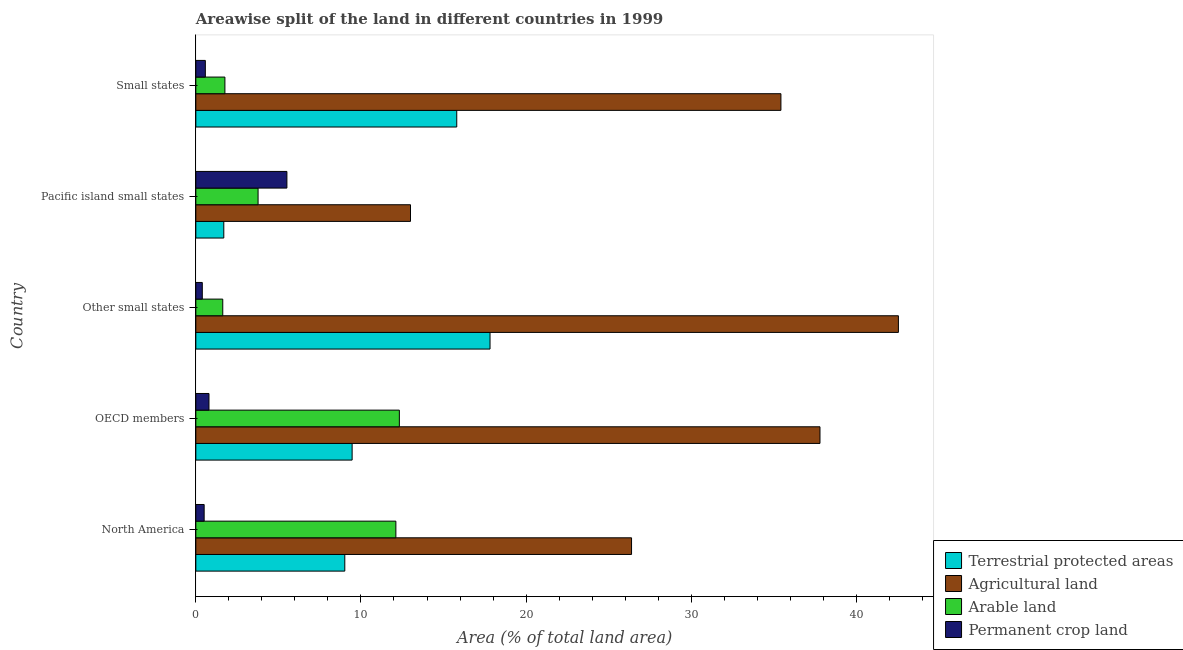Are the number of bars per tick equal to the number of legend labels?
Make the answer very short. Yes. How many bars are there on the 3rd tick from the top?
Your response must be concise. 4. In how many cases, is the number of bars for a given country not equal to the number of legend labels?
Make the answer very short. 0. What is the percentage of land under terrestrial protection in Pacific island small states?
Give a very brief answer. 1.69. Across all countries, what is the maximum percentage of land under terrestrial protection?
Keep it short and to the point. 17.82. Across all countries, what is the minimum percentage of land under terrestrial protection?
Your response must be concise. 1.69. In which country was the percentage of land under terrestrial protection maximum?
Your response must be concise. Other small states. In which country was the percentage of area under agricultural land minimum?
Your answer should be very brief. Pacific island small states. What is the total percentage of area under permanent crop land in the graph?
Ensure brevity in your answer.  7.78. What is the difference between the percentage of land under terrestrial protection in North America and that in Other small states?
Make the answer very short. -8.79. What is the difference between the percentage of land under terrestrial protection in Pacific island small states and the percentage of area under permanent crop land in Small states?
Your answer should be very brief. 1.12. What is the average percentage of area under permanent crop land per country?
Provide a short and direct response. 1.56. What is the difference between the percentage of land under terrestrial protection and percentage of area under agricultural land in North America?
Ensure brevity in your answer.  -17.36. In how many countries, is the percentage of area under permanent crop land greater than 30 %?
Your answer should be compact. 0. What is the ratio of the percentage of area under arable land in North America to that in Other small states?
Provide a short and direct response. 7.43. Is the percentage of area under agricultural land in OECD members less than that in Pacific island small states?
Your answer should be very brief. No. Is the difference between the percentage of area under arable land in OECD members and Small states greater than the difference between the percentage of area under permanent crop land in OECD members and Small states?
Provide a short and direct response. Yes. What is the difference between the highest and the second highest percentage of area under permanent crop land?
Your answer should be very brief. 4.72. What is the difference between the highest and the lowest percentage of area under arable land?
Your answer should be very brief. 10.69. Is it the case that in every country, the sum of the percentage of land under terrestrial protection and percentage of area under arable land is greater than the sum of percentage of area under agricultural land and percentage of area under permanent crop land?
Provide a short and direct response. Yes. What does the 2nd bar from the top in North America represents?
Give a very brief answer. Arable land. What does the 1st bar from the bottom in Other small states represents?
Keep it short and to the point. Terrestrial protected areas. Are all the bars in the graph horizontal?
Offer a terse response. Yes. How many countries are there in the graph?
Provide a short and direct response. 5. What is the difference between two consecutive major ticks on the X-axis?
Make the answer very short. 10. Does the graph contain any zero values?
Keep it short and to the point. No. Does the graph contain grids?
Keep it short and to the point. No. How are the legend labels stacked?
Ensure brevity in your answer.  Vertical. What is the title of the graph?
Provide a succinct answer. Areawise split of the land in different countries in 1999. What is the label or title of the X-axis?
Make the answer very short. Area (% of total land area). What is the Area (% of total land area) of Terrestrial protected areas in North America?
Give a very brief answer. 9.02. What is the Area (% of total land area) of Agricultural land in North America?
Offer a very short reply. 26.39. What is the Area (% of total land area) in Arable land in North America?
Make the answer very short. 12.11. What is the Area (% of total land area) of Permanent crop land in North America?
Provide a short and direct response. 0.5. What is the Area (% of total land area) of Terrestrial protected areas in OECD members?
Your response must be concise. 9.47. What is the Area (% of total land area) in Agricultural land in OECD members?
Offer a very short reply. 37.8. What is the Area (% of total land area) of Arable land in OECD members?
Keep it short and to the point. 12.32. What is the Area (% of total land area) of Permanent crop land in OECD members?
Your answer should be compact. 0.8. What is the Area (% of total land area) of Terrestrial protected areas in Other small states?
Keep it short and to the point. 17.82. What is the Area (% of total land area) in Agricultural land in Other small states?
Keep it short and to the point. 42.55. What is the Area (% of total land area) of Arable land in Other small states?
Your answer should be compact. 1.63. What is the Area (% of total land area) of Permanent crop land in Other small states?
Make the answer very short. 0.39. What is the Area (% of total land area) of Terrestrial protected areas in Pacific island small states?
Offer a very short reply. 1.69. What is the Area (% of total land area) in Agricultural land in Pacific island small states?
Make the answer very short. 13. What is the Area (% of total land area) of Arable land in Pacific island small states?
Your answer should be compact. 3.77. What is the Area (% of total land area) in Permanent crop land in Pacific island small states?
Give a very brief answer. 5.52. What is the Area (% of total land area) in Terrestrial protected areas in Small states?
Your response must be concise. 15.8. What is the Area (% of total land area) of Agricultural land in Small states?
Your answer should be very brief. 35.43. What is the Area (% of total land area) of Arable land in Small states?
Offer a very short reply. 1.76. What is the Area (% of total land area) of Permanent crop land in Small states?
Your answer should be very brief. 0.58. Across all countries, what is the maximum Area (% of total land area) in Terrestrial protected areas?
Ensure brevity in your answer.  17.82. Across all countries, what is the maximum Area (% of total land area) of Agricultural land?
Provide a short and direct response. 42.55. Across all countries, what is the maximum Area (% of total land area) in Arable land?
Provide a short and direct response. 12.32. Across all countries, what is the maximum Area (% of total land area) in Permanent crop land?
Give a very brief answer. 5.52. Across all countries, what is the minimum Area (% of total land area) in Terrestrial protected areas?
Offer a very short reply. 1.69. Across all countries, what is the minimum Area (% of total land area) of Agricultural land?
Make the answer very short. 13. Across all countries, what is the minimum Area (% of total land area) in Arable land?
Give a very brief answer. 1.63. Across all countries, what is the minimum Area (% of total land area) of Permanent crop land?
Ensure brevity in your answer.  0.39. What is the total Area (% of total land area) of Terrestrial protected areas in the graph?
Your answer should be very brief. 53.8. What is the total Area (% of total land area) of Agricultural land in the graph?
Your answer should be compact. 155.16. What is the total Area (% of total land area) in Arable land in the graph?
Your answer should be compact. 31.6. What is the total Area (% of total land area) in Permanent crop land in the graph?
Your answer should be compact. 7.78. What is the difference between the Area (% of total land area) in Terrestrial protected areas in North America and that in OECD members?
Offer a very short reply. -0.44. What is the difference between the Area (% of total land area) of Agricultural land in North America and that in OECD members?
Offer a terse response. -11.41. What is the difference between the Area (% of total land area) of Arable land in North America and that in OECD members?
Offer a terse response. -0.21. What is the difference between the Area (% of total land area) of Permanent crop land in North America and that in OECD members?
Your answer should be compact. -0.29. What is the difference between the Area (% of total land area) of Terrestrial protected areas in North America and that in Other small states?
Ensure brevity in your answer.  -8.79. What is the difference between the Area (% of total land area) in Agricultural land in North America and that in Other small states?
Ensure brevity in your answer.  -16.16. What is the difference between the Area (% of total land area) of Arable land in North America and that in Other small states?
Ensure brevity in your answer.  10.48. What is the difference between the Area (% of total land area) of Permanent crop land in North America and that in Other small states?
Offer a terse response. 0.11. What is the difference between the Area (% of total land area) in Terrestrial protected areas in North America and that in Pacific island small states?
Offer a very short reply. 7.33. What is the difference between the Area (% of total land area) of Agricultural land in North America and that in Pacific island small states?
Keep it short and to the point. 13.39. What is the difference between the Area (% of total land area) of Arable land in North America and that in Pacific island small states?
Offer a terse response. 8.34. What is the difference between the Area (% of total land area) of Permanent crop land in North America and that in Pacific island small states?
Offer a very short reply. -5.01. What is the difference between the Area (% of total land area) in Terrestrial protected areas in North America and that in Small states?
Make the answer very short. -6.78. What is the difference between the Area (% of total land area) of Agricultural land in North America and that in Small states?
Give a very brief answer. -9.05. What is the difference between the Area (% of total land area) of Arable land in North America and that in Small states?
Make the answer very short. 10.35. What is the difference between the Area (% of total land area) of Permanent crop land in North America and that in Small states?
Give a very brief answer. -0.07. What is the difference between the Area (% of total land area) in Terrestrial protected areas in OECD members and that in Other small states?
Offer a terse response. -8.35. What is the difference between the Area (% of total land area) of Agricultural land in OECD members and that in Other small states?
Ensure brevity in your answer.  -4.75. What is the difference between the Area (% of total land area) of Arable land in OECD members and that in Other small states?
Give a very brief answer. 10.69. What is the difference between the Area (% of total land area) in Permanent crop land in OECD members and that in Other small states?
Your answer should be very brief. 0.4. What is the difference between the Area (% of total land area) of Terrestrial protected areas in OECD members and that in Pacific island small states?
Provide a succinct answer. 7.77. What is the difference between the Area (% of total land area) in Agricultural land in OECD members and that in Pacific island small states?
Provide a succinct answer. 24.8. What is the difference between the Area (% of total land area) of Arable land in OECD members and that in Pacific island small states?
Your answer should be compact. 8.56. What is the difference between the Area (% of total land area) of Permanent crop land in OECD members and that in Pacific island small states?
Provide a short and direct response. -4.72. What is the difference between the Area (% of total land area) in Terrestrial protected areas in OECD members and that in Small states?
Ensure brevity in your answer.  -6.33. What is the difference between the Area (% of total land area) of Agricultural land in OECD members and that in Small states?
Give a very brief answer. 2.37. What is the difference between the Area (% of total land area) of Arable land in OECD members and that in Small states?
Provide a succinct answer. 10.56. What is the difference between the Area (% of total land area) in Permanent crop land in OECD members and that in Small states?
Your answer should be very brief. 0.22. What is the difference between the Area (% of total land area) in Terrestrial protected areas in Other small states and that in Pacific island small states?
Your answer should be very brief. 16.12. What is the difference between the Area (% of total land area) in Agricultural land in Other small states and that in Pacific island small states?
Keep it short and to the point. 29.55. What is the difference between the Area (% of total land area) in Arable land in Other small states and that in Pacific island small states?
Ensure brevity in your answer.  -2.14. What is the difference between the Area (% of total land area) of Permanent crop land in Other small states and that in Pacific island small states?
Provide a short and direct response. -5.12. What is the difference between the Area (% of total land area) of Terrestrial protected areas in Other small states and that in Small states?
Offer a terse response. 2.02. What is the difference between the Area (% of total land area) in Agricultural land in Other small states and that in Small states?
Offer a terse response. 7.11. What is the difference between the Area (% of total land area) in Arable land in Other small states and that in Small states?
Provide a succinct answer. -0.13. What is the difference between the Area (% of total land area) in Permanent crop land in Other small states and that in Small states?
Your response must be concise. -0.18. What is the difference between the Area (% of total land area) in Terrestrial protected areas in Pacific island small states and that in Small states?
Your answer should be compact. -14.11. What is the difference between the Area (% of total land area) in Agricultural land in Pacific island small states and that in Small states?
Your response must be concise. -22.43. What is the difference between the Area (% of total land area) in Arable land in Pacific island small states and that in Small states?
Offer a very short reply. 2.01. What is the difference between the Area (% of total land area) of Permanent crop land in Pacific island small states and that in Small states?
Make the answer very short. 4.94. What is the difference between the Area (% of total land area) of Terrestrial protected areas in North America and the Area (% of total land area) of Agricultural land in OECD members?
Keep it short and to the point. -28.78. What is the difference between the Area (% of total land area) of Terrestrial protected areas in North America and the Area (% of total land area) of Arable land in OECD members?
Offer a terse response. -3.3. What is the difference between the Area (% of total land area) in Terrestrial protected areas in North America and the Area (% of total land area) in Permanent crop land in OECD members?
Provide a succinct answer. 8.22. What is the difference between the Area (% of total land area) of Agricultural land in North America and the Area (% of total land area) of Arable land in OECD members?
Your answer should be very brief. 14.06. What is the difference between the Area (% of total land area) of Agricultural land in North America and the Area (% of total land area) of Permanent crop land in OECD members?
Offer a terse response. 25.59. What is the difference between the Area (% of total land area) of Arable land in North America and the Area (% of total land area) of Permanent crop land in OECD members?
Give a very brief answer. 11.32. What is the difference between the Area (% of total land area) of Terrestrial protected areas in North America and the Area (% of total land area) of Agricultural land in Other small states?
Your answer should be compact. -33.52. What is the difference between the Area (% of total land area) in Terrestrial protected areas in North America and the Area (% of total land area) in Arable land in Other small states?
Ensure brevity in your answer.  7.39. What is the difference between the Area (% of total land area) of Terrestrial protected areas in North America and the Area (% of total land area) of Permanent crop land in Other small states?
Provide a short and direct response. 8.63. What is the difference between the Area (% of total land area) of Agricultural land in North America and the Area (% of total land area) of Arable land in Other small states?
Make the answer very short. 24.75. What is the difference between the Area (% of total land area) in Agricultural land in North America and the Area (% of total land area) in Permanent crop land in Other small states?
Ensure brevity in your answer.  25.99. What is the difference between the Area (% of total land area) of Arable land in North America and the Area (% of total land area) of Permanent crop land in Other small states?
Your response must be concise. 11.72. What is the difference between the Area (% of total land area) in Terrestrial protected areas in North America and the Area (% of total land area) in Agricultural land in Pacific island small states?
Provide a short and direct response. -3.98. What is the difference between the Area (% of total land area) in Terrestrial protected areas in North America and the Area (% of total land area) in Arable land in Pacific island small states?
Offer a terse response. 5.25. What is the difference between the Area (% of total land area) of Terrestrial protected areas in North America and the Area (% of total land area) of Permanent crop land in Pacific island small states?
Keep it short and to the point. 3.51. What is the difference between the Area (% of total land area) in Agricultural land in North America and the Area (% of total land area) in Arable land in Pacific island small states?
Give a very brief answer. 22.62. What is the difference between the Area (% of total land area) in Agricultural land in North America and the Area (% of total land area) in Permanent crop land in Pacific island small states?
Give a very brief answer. 20.87. What is the difference between the Area (% of total land area) in Arable land in North America and the Area (% of total land area) in Permanent crop land in Pacific island small states?
Provide a succinct answer. 6.6. What is the difference between the Area (% of total land area) of Terrestrial protected areas in North America and the Area (% of total land area) of Agricultural land in Small states?
Your response must be concise. -26.41. What is the difference between the Area (% of total land area) of Terrestrial protected areas in North America and the Area (% of total land area) of Arable land in Small states?
Your answer should be compact. 7.26. What is the difference between the Area (% of total land area) in Terrestrial protected areas in North America and the Area (% of total land area) in Permanent crop land in Small states?
Provide a short and direct response. 8.45. What is the difference between the Area (% of total land area) of Agricultural land in North America and the Area (% of total land area) of Arable land in Small states?
Your response must be concise. 24.63. What is the difference between the Area (% of total land area) of Agricultural land in North America and the Area (% of total land area) of Permanent crop land in Small states?
Provide a short and direct response. 25.81. What is the difference between the Area (% of total land area) in Arable land in North America and the Area (% of total land area) in Permanent crop land in Small states?
Ensure brevity in your answer.  11.54. What is the difference between the Area (% of total land area) in Terrestrial protected areas in OECD members and the Area (% of total land area) in Agricultural land in Other small states?
Provide a short and direct response. -33.08. What is the difference between the Area (% of total land area) of Terrestrial protected areas in OECD members and the Area (% of total land area) of Arable land in Other small states?
Keep it short and to the point. 7.83. What is the difference between the Area (% of total land area) of Terrestrial protected areas in OECD members and the Area (% of total land area) of Permanent crop land in Other small states?
Ensure brevity in your answer.  9.07. What is the difference between the Area (% of total land area) of Agricultural land in OECD members and the Area (% of total land area) of Arable land in Other small states?
Keep it short and to the point. 36.17. What is the difference between the Area (% of total land area) in Agricultural land in OECD members and the Area (% of total land area) in Permanent crop land in Other small states?
Your response must be concise. 37.4. What is the difference between the Area (% of total land area) in Arable land in OECD members and the Area (% of total land area) in Permanent crop land in Other small states?
Make the answer very short. 11.93. What is the difference between the Area (% of total land area) of Terrestrial protected areas in OECD members and the Area (% of total land area) of Agricultural land in Pacific island small states?
Provide a succinct answer. -3.53. What is the difference between the Area (% of total land area) of Terrestrial protected areas in OECD members and the Area (% of total land area) of Arable land in Pacific island small states?
Provide a succinct answer. 5.7. What is the difference between the Area (% of total land area) of Terrestrial protected areas in OECD members and the Area (% of total land area) of Permanent crop land in Pacific island small states?
Offer a very short reply. 3.95. What is the difference between the Area (% of total land area) of Agricultural land in OECD members and the Area (% of total land area) of Arable land in Pacific island small states?
Make the answer very short. 34.03. What is the difference between the Area (% of total land area) of Agricultural land in OECD members and the Area (% of total land area) of Permanent crop land in Pacific island small states?
Make the answer very short. 32.28. What is the difference between the Area (% of total land area) of Arable land in OECD members and the Area (% of total land area) of Permanent crop land in Pacific island small states?
Keep it short and to the point. 6.81. What is the difference between the Area (% of total land area) in Terrestrial protected areas in OECD members and the Area (% of total land area) in Agricultural land in Small states?
Your answer should be very brief. -25.97. What is the difference between the Area (% of total land area) in Terrestrial protected areas in OECD members and the Area (% of total land area) in Arable land in Small states?
Give a very brief answer. 7.7. What is the difference between the Area (% of total land area) of Terrestrial protected areas in OECD members and the Area (% of total land area) of Permanent crop land in Small states?
Your response must be concise. 8.89. What is the difference between the Area (% of total land area) in Agricultural land in OECD members and the Area (% of total land area) in Arable land in Small states?
Ensure brevity in your answer.  36.04. What is the difference between the Area (% of total land area) in Agricultural land in OECD members and the Area (% of total land area) in Permanent crop land in Small states?
Offer a terse response. 37.22. What is the difference between the Area (% of total land area) in Arable land in OECD members and the Area (% of total land area) in Permanent crop land in Small states?
Provide a succinct answer. 11.75. What is the difference between the Area (% of total land area) in Terrestrial protected areas in Other small states and the Area (% of total land area) in Agricultural land in Pacific island small states?
Make the answer very short. 4.82. What is the difference between the Area (% of total land area) in Terrestrial protected areas in Other small states and the Area (% of total land area) in Arable land in Pacific island small states?
Ensure brevity in your answer.  14.05. What is the difference between the Area (% of total land area) in Terrestrial protected areas in Other small states and the Area (% of total land area) in Permanent crop land in Pacific island small states?
Provide a short and direct response. 12.3. What is the difference between the Area (% of total land area) in Agricultural land in Other small states and the Area (% of total land area) in Arable land in Pacific island small states?
Ensure brevity in your answer.  38.78. What is the difference between the Area (% of total land area) in Agricultural land in Other small states and the Area (% of total land area) in Permanent crop land in Pacific island small states?
Offer a terse response. 37.03. What is the difference between the Area (% of total land area) of Arable land in Other small states and the Area (% of total land area) of Permanent crop land in Pacific island small states?
Your answer should be very brief. -3.88. What is the difference between the Area (% of total land area) in Terrestrial protected areas in Other small states and the Area (% of total land area) in Agricultural land in Small states?
Your response must be concise. -17.62. What is the difference between the Area (% of total land area) in Terrestrial protected areas in Other small states and the Area (% of total land area) in Arable land in Small states?
Offer a very short reply. 16.06. What is the difference between the Area (% of total land area) of Terrestrial protected areas in Other small states and the Area (% of total land area) of Permanent crop land in Small states?
Give a very brief answer. 17.24. What is the difference between the Area (% of total land area) in Agricultural land in Other small states and the Area (% of total land area) in Arable land in Small states?
Make the answer very short. 40.79. What is the difference between the Area (% of total land area) of Agricultural land in Other small states and the Area (% of total land area) of Permanent crop land in Small states?
Offer a very short reply. 41.97. What is the difference between the Area (% of total land area) in Arable land in Other small states and the Area (% of total land area) in Permanent crop land in Small states?
Ensure brevity in your answer.  1.06. What is the difference between the Area (% of total land area) in Terrestrial protected areas in Pacific island small states and the Area (% of total land area) in Agricultural land in Small states?
Ensure brevity in your answer.  -33.74. What is the difference between the Area (% of total land area) of Terrestrial protected areas in Pacific island small states and the Area (% of total land area) of Arable land in Small states?
Offer a very short reply. -0.07. What is the difference between the Area (% of total land area) in Terrestrial protected areas in Pacific island small states and the Area (% of total land area) in Permanent crop land in Small states?
Make the answer very short. 1.12. What is the difference between the Area (% of total land area) of Agricultural land in Pacific island small states and the Area (% of total land area) of Arable land in Small states?
Make the answer very short. 11.24. What is the difference between the Area (% of total land area) of Agricultural land in Pacific island small states and the Area (% of total land area) of Permanent crop land in Small states?
Provide a short and direct response. 12.42. What is the difference between the Area (% of total land area) in Arable land in Pacific island small states and the Area (% of total land area) in Permanent crop land in Small states?
Give a very brief answer. 3.19. What is the average Area (% of total land area) in Terrestrial protected areas per country?
Provide a short and direct response. 10.76. What is the average Area (% of total land area) in Agricultural land per country?
Ensure brevity in your answer.  31.03. What is the average Area (% of total land area) of Arable land per country?
Ensure brevity in your answer.  6.32. What is the average Area (% of total land area) in Permanent crop land per country?
Give a very brief answer. 1.56. What is the difference between the Area (% of total land area) in Terrestrial protected areas and Area (% of total land area) in Agricultural land in North America?
Your answer should be compact. -17.36. What is the difference between the Area (% of total land area) in Terrestrial protected areas and Area (% of total land area) in Arable land in North America?
Ensure brevity in your answer.  -3.09. What is the difference between the Area (% of total land area) in Terrestrial protected areas and Area (% of total land area) in Permanent crop land in North America?
Your response must be concise. 8.52. What is the difference between the Area (% of total land area) of Agricultural land and Area (% of total land area) of Arable land in North America?
Your response must be concise. 14.27. What is the difference between the Area (% of total land area) in Agricultural land and Area (% of total land area) in Permanent crop land in North America?
Provide a succinct answer. 25.88. What is the difference between the Area (% of total land area) of Arable land and Area (% of total land area) of Permanent crop land in North America?
Keep it short and to the point. 11.61. What is the difference between the Area (% of total land area) of Terrestrial protected areas and Area (% of total land area) of Agricultural land in OECD members?
Your response must be concise. -28.33. What is the difference between the Area (% of total land area) in Terrestrial protected areas and Area (% of total land area) in Arable land in OECD members?
Provide a short and direct response. -2.86. What is the difference between the Area (% of total land area) in Terrestrial protected areas and Area (% of total land area) in Permanent crop land in OECD members?
Make the answer very short. 8.67. What is the difference between the Area (% of total land area) in Agricultural land and Area (% of total land area) in Arable land in OECD members?
Your answer should be very brief. 25.47. What is the difference between the Area (% of total land area) of Agricultural land and Area (% of total land area) of Permanent crop land in OECD members?
Your answer should be very brief. 37. What is the difference between the Area (% of total land area) of Arable land and Area (% of total land area) of Permanent crop land in OECD members?
Keep it short and to the point. 11.53. What is the difference between the Area (% of total land area) in Terrestrial protected areas and Area (% of total land area) in Agricultural land in Other small states?
Provide a succinct answer. -24.73. What is the difference between the Area (% of total land area) in Terrestrial protected areas and Area (% of total land area) in Arable land in Other small states?
Make the answer very short. 16.18. What is the difference between the Area (% of total land area) in Terrestrial protected areas and Area (% of total land area) in Permanent crop land in Other small states?
Your answer should be very brief. 17.42. What is the difference between the Area (% of total land area) of Agricultural land and Area (% of total land area) of Arable land in Other small states?
Provide a succinct answer. 40.91. What is the difference between the Area (% of total land area) in Agricultural land and Area (% of total land area) in Permanent crop land in Other small states?
Ensure brevity in your answer.  42.15. What is the difference between the Area (% of total land area) of Arable land and Area (% of total land area) of Permanent crop land in Other small states?
Offer a very short reply. 1.24. What is the difference between the Area (% of total land area) of Terrestrial protected areas and Area (% of total land area) of Agricultural land in Pacific island small states?
Provide a short and direct response. -11.31. What is the difference between the Area (% of total land area) in Terrestrial protected areas and Area (% of total land area) in Arable land in Pacific island small states?
Ensure brevity in your answer.  -2.08. What is the difference between the Area (% of total land area) of Terrestrial protected areas and Area (% of total land area) of Permanent crop land in Pacific island small states?
Ensure brevity in your answer.  -3.82. What is the difference between the Area (% of total land area) in Agricultural land and Area (% of total land area) in Arable land in Pacific island small states?
Keep it short and to the point. 9.23. What is the difference between the Area (% of total land area) in Agricultural land and Area (% of total land area) in Permanent crop land in Pacific island small states?
Ensure brevity in your answer.  7.48. What is the difference between the Area (% of total land area) of Arable land and Area (% of total land area) of Permanent crop land in Pacific island small states?
Keep it short and to the point. -1.75. What is the difference between the Area (% of total land area) of Terrestrial protected areas and Area (% of total land area) of Agricultural land in Small states?
Offer a very short reply. -19.63. What is the difference between the Area (% of total land area) in Terrestrial protected areas and Area (% of total land area) in Arable land in Small states?
Offer a very short reply. 14.04. What is the difference between the Area (% of total land area) of Terrestrial protected areas and Area (% of total land area) of Permanent crop land in Small states?
Provide a short and direct response. 15.22. What is the difference between the Area (% of total land area) of Agricultural land and Area (% of total land area) of Arable land in Small states?
Offer a very short reply. 33.67. What is the difference between the Area (% of total land area) of Agricultural land and Area (% of total land area) of Permanent crop land in Small states?
Provide a succinct answer. 34.86. What is the difference between the Area (% of total land area) of Arable land and Area (% of total land area) of Permanent crop land in Small states?
Provide a succinct answer. 1.18. What is the ratio of the Area (% of total land area) in Terrestrial protected areas in North America to that in OECD members?
Ensure brevity in your answer.  0.95. What is the ratio of the Area (% of total land area) of Agricultural land in North America to that in OECD members?
Your response must be concise. 0.7. What is the ratio of the Area (% of total land area) of Arable land in North America to that in OECD members?
Your answer should be compact. 0.98. What is the ratio of the Area (% of total land area) in Permanent crop land in North America to that in OECD members?
Your answer should be very brief. 0.63. What is the ratio of the Area (% of total land area) of Terrestrial protected areas in North America to that in Other small states?
Your response must be concise. 0.51. What is the ratio of the Area (% of total land area) of Agricultural land in North America to that in Other small states?
Provide a short and direct response. 0.62. What is the ratio of the Area (% of total land area) in Arable land in North America to that in Other small states?
Your answer should be compact. 7.43. What is the ratio of the Area (% of total land area) in Permanent crop land in North America to that in Other small states?
Your response must be concise. 1.29. What is the ratio of the Area (% of total land area) in Terrestrial protected areas in North America to that in Pacific island small states?
Give a very brief answer. 5.33. What is the ratio of the Area (% of total land area) of Agricultural land in North America to that in Pacific island small states?
Provide a succinct answer. 2.03. What is the ratio of the Area (% of total land area) of Arable land in North America to that in Pacific island small states?
Your answer should be very brief. 3.21. What is the ratio of the Area (% of total land area) in Permanent crop land in North America to that in Pacific island small states?
Your response must be concise. 0.09. What is the ratio of the Area (% of total land area) in Terrestrial protected areas in North America to that in Small states?
Your response must be concise. 0.57. What is the ratio of the Area (% of total land area) of Agricultural land in North America to that in Small states?
Your answer should be compact. 0.74. What is the ratio of the Area (% of total land area) of Arable land in North America to that in Small states?
Offer a very short reply. 6.88. What is the ratio of the Area (% of total land area) of Permanent crop land in North America to that in Small states?
Your answer should be very brief. 0.88. What is the ratio of the Area (% of total land area) in Terrestrial protected areas in OECD members to that in Other small states?
Your answer should be compact. 0.53. What is the ratio of the Area (% of total land area) in Agricultural land in OECD members to that in Other small states?
Your response must be concise. 0.89. What is the ratio of the Area (% of total land area) of Arable land in OECD members to that in Other small states?
Your answer should be very brief. 7.56. What is the ratio of the Area (% of total land area) of Permanent crop land in OECD members to that in Other small states?
Keep it short and to the point. 2.03. What is the ratio of the Area (% of total land area) in Terrestrial protected areas in OECD members to that in Pacific island small states?
Make the answer very short. 5.59. What is the ratio of the Area (% of total land area) of Agricultural land in OECD members to that in Pacific island small states?
Give a very brief answer. 2.91. What is the ratio of the Area (% of total land area) of Arable land in OECD members to that in Pacific island small states?
Provide a short and direct response. 3.27. What is the ratio of the Area (% of total land area) of Permanent crop land in OECD members to that in Pacific island small states?
Make the answer very short. 0.14. What is the ratio of the Area (% of total land area) of Terrestrial protected areas in OECD members to that in Small states?
Provide a short and direct response. 0.6. What is the ratio of the Area (% of total land area) in Agricultural land in OECD members to that in Small states?
Provide a succinct answer. 1.07. What is the ratio of the Area (% of total land area) of Arable land in OECD members to that in Small states?
Your answer should be compact. 7. What is the ratio of the Area (% of total land area) in Permanent crop land in OECD members to that in Small states?
Your answer should be compact. 1.38. What is the ratio of the Area (% of total land area) in Terrestrial protected areas in Other small states to that in Pacific island small states?
Offer a very short reply. 10.52. What is the ratio of the Area (% of total land area) of Agricultural land in Other small states to that in Pacific island small states?
Give a very brief answer. 3.27. What is the ratio of the Area (% of total land area) of Arable land in Other small states to that in Pacific island small states?
Offer a terse response. 0.43. What is the ratio of the Area (% of total land area) of Permanent crop land in Other small states to that in Pacific island small states?
Give a very brief answer. 0.07. What is the ratio of the Area (% of total land area) in Terrestrial protected areas in Other small states to that in Small states?
Offer a terse response. 1.13. What is the ratio of the Area (% of total land area) in Agricultural land in Other small states to that in Small states?
Offer a terse response. 1.2. What is the ratio of the Area (% of total land area) in Arable land in Other small states to that in Small states?
Offer a very short reply. 0.93. What is the ratio of the Area (% of total land area) of Permanent crop land in Other small states to that in Small states?
Offer a very short reply. 0.68. What is the ratio of the Area (% of total land area) in Terrestrial protected areas in Pacific island small states to that in Small states?
Provide a succinct answer. 0.11. What is the ratio of the Area (% of total land area) of Agricultural land in Pacific island small states to that in Small states?
Offer a terse response. 0.37. What is the ratio of the Area (% of total land area) of Arable land in Pacific island small states to that in Small states?
Offer a very short reply. 2.14. What is the ratio of the Area (% of total land area) of Permanent crop land in Pacific island small states to that in Small states?
Keep it short and to the point. 9.57. What is the difference between the highest and the second highest Area (% of total land area) in Terrestrial protected areas?
Your answer should be very brief. 2.02. What is the difference between the highest and the second highest Area (% of total land area) in Agricultural land?
Ensure brevity in your answer.  4.75. What is the difference between the highest and the second highest Area (% of total land area) in Arable land?
Give a very brief answer. 0.21. What is the difference between the highest and the second highest Area (% of total land area) in Permanent crop land?
Make the answer very short. 4.72. What is the difference between the highest and the lowest Area (% of total land area) of Terrestrial protected areas?
Your response must be concise. 16.12. What is the difference between the highest and the lowest Area (% of total land area) of Agricultural land?
Give a very brief answer. 29.55. What is the difference between the highest and the lowest Area (% of total land area) of Arable land?
Provide a succinct answer. 10.69. What is the difference between the highest and the lowest Area (% of total land area) in Permanent crop land?
Make the answer very short. 5.12. 